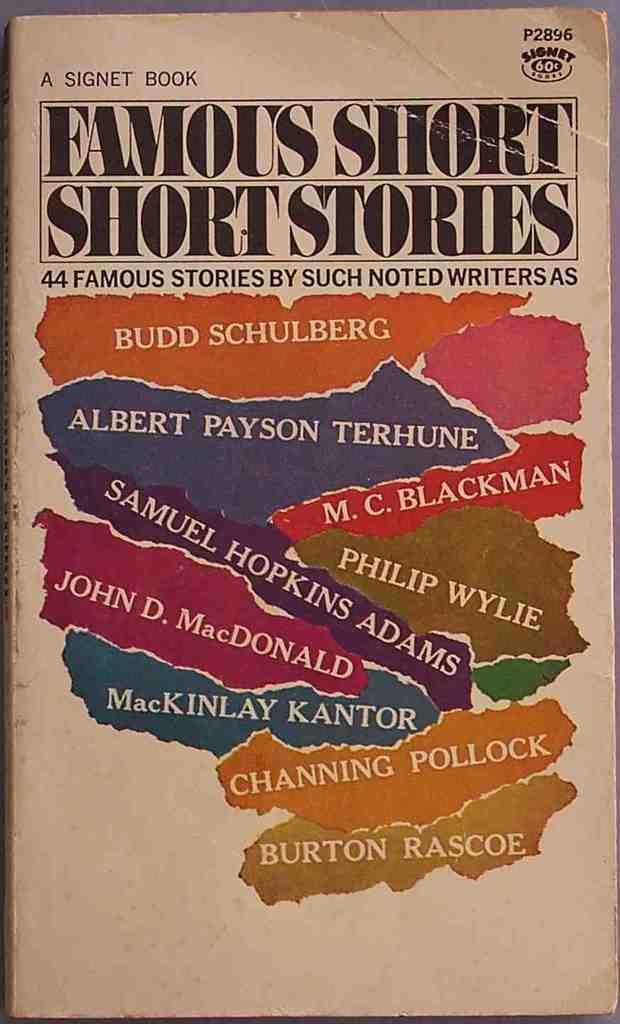Who published this book?
Keep it short and to the point. Signet. 